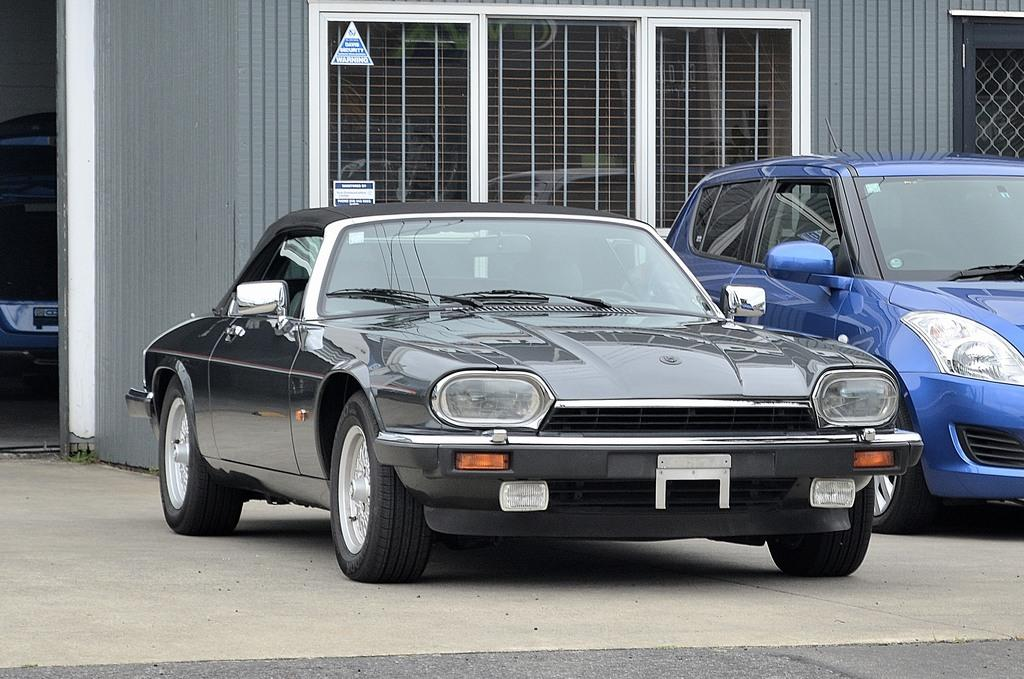What is the main subject of the image? The main subject of the image is a car parked on a path. Are there any other cars in the image? Yes, there is another car beside the parked car. What can be seen behind the cars in the image? There is a wall with a window visible behind the cars. How many mice can be seen running along the parked car in the image? There are no mice present in the image. 